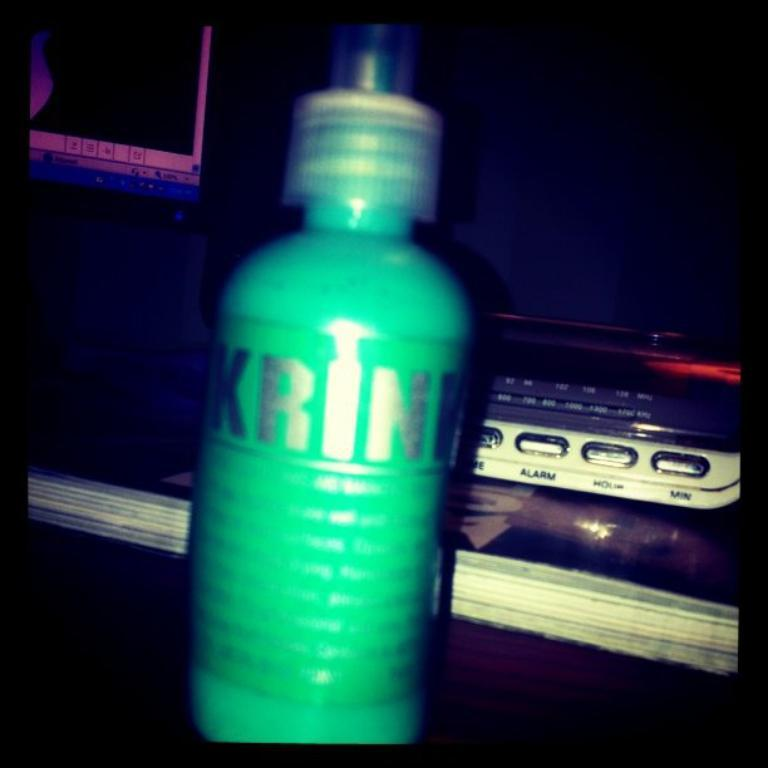What color is the bottle that is visible in the image? There is a green bottle in the image. What is written on the bottle? There is writing on the bottle. How does the pear contribute to pollution in the image? There is no pear present in the image, so it cannot contribute to pollution. 